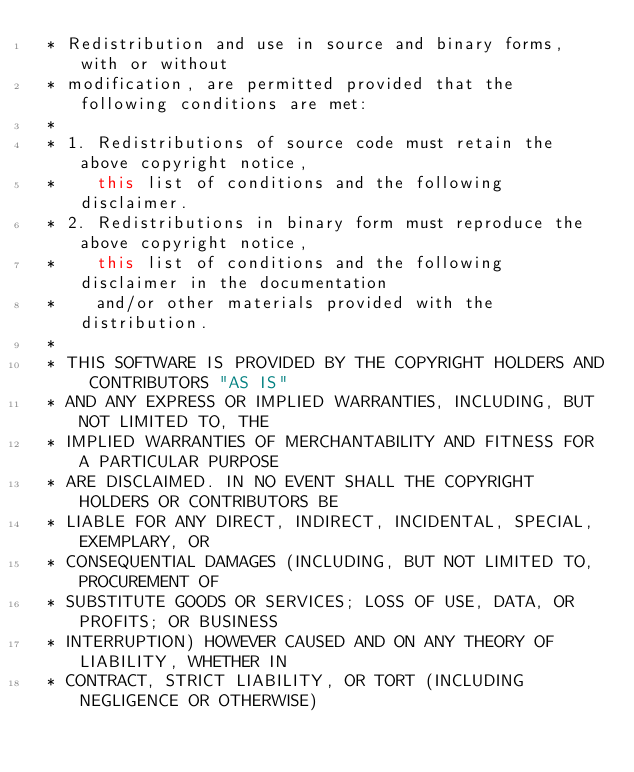<code> <loc_0><loc_0><loc_500><loc_500><_Java_> * Redistribution and use in source and binary forms, with or without
 * modification, are permitted provided that the following conditions are met:
 * 
 * 1. Redistributions of source code must retain the above copyright notice,
 *    this list of conditions and the following disclaimer.
 * 2. Redistributions in binary form must reproduce the above copyright notice,
 *    this list of conditions and the following disclaimer in the documentation
 *    and/or other materials provided with the distribution.
 * 
 * THIS SOFTWARE IS PROVIDED BY THE COPYRIGHT HOLDERS AND CONTRIBUTORS "AS IS"
 * AND ANY EXPRESS OR IMPLIED WARRANTIES, INCLUDING, BUT NOT LIMITED TO, THE
 * IMPLIED WARRANTIES OF MERCHANTABILITY AND FITNESS FOR A PARTICULAR PURPOSE
 * ARE DISCLAIMED. IN NO EVENT SHALL THE COPYRIGHT HOLDERS OR CONTRIBUTORS BE
 * LIABLE FOR ANY DIRECT, INDIRECT, INCIDENTAL, SPECIAL, EXEMPLARY, OR
 * CONSEQUENTIAL DAMAGES (INCLUDING, BUT NOT LIMITED TO, PROCUREMENT OF
 * SUBSTITUTE GOODS OR SERVICES; LOSS OF USE, DATA, OR PROFITS; OR BUSINESS
 * INTERRUPTION) HOWEVER CAUSED AND ON ANY THEORY OF LIABILITY, WHETHER IN
 * CONTRACT, STRICT LIABILITY, OR TORT (INCLUDING NEGLIGENCE OR OTHERWISE)</code> 